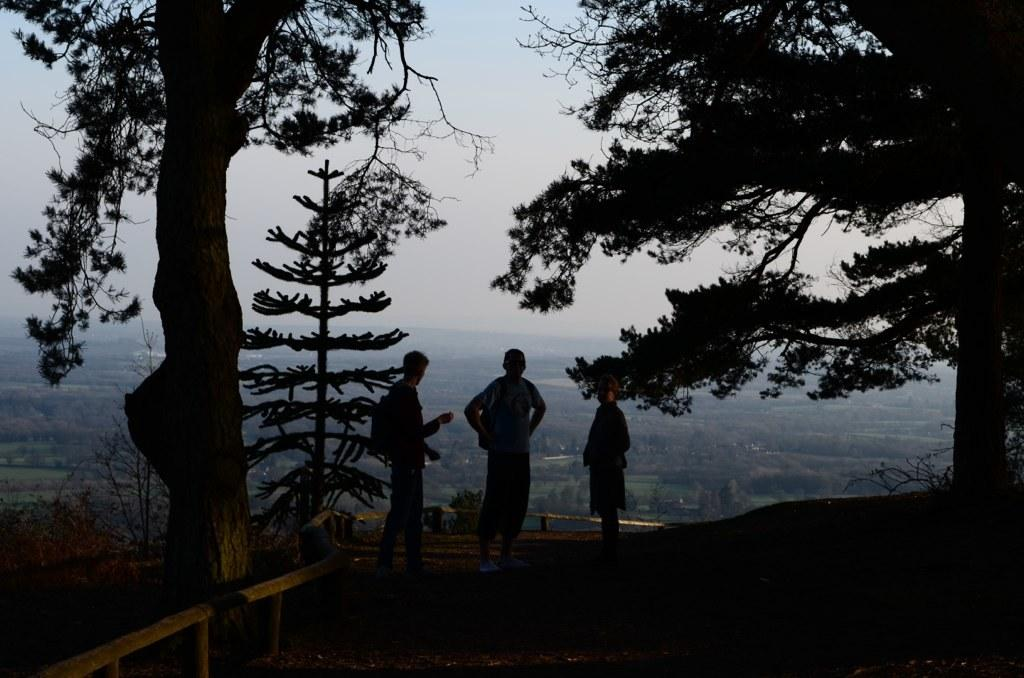What is the main subject in the center of the image? There are people in the center of the image. What type of natural elements can be seen in the image? There are trees and hills visible in the image. What is visible in the background of the image? The sky is visible in the background of the image. What is located on the left side of the image? There is a fence on the left side of the image. What color of paint is being used on the range in the image? There is no range or paint present in the image. How many items can be found in the pocket of the person on the right side of the image? There is no person on the right side of the image, and pockets are not mentioned in the provided facts. 